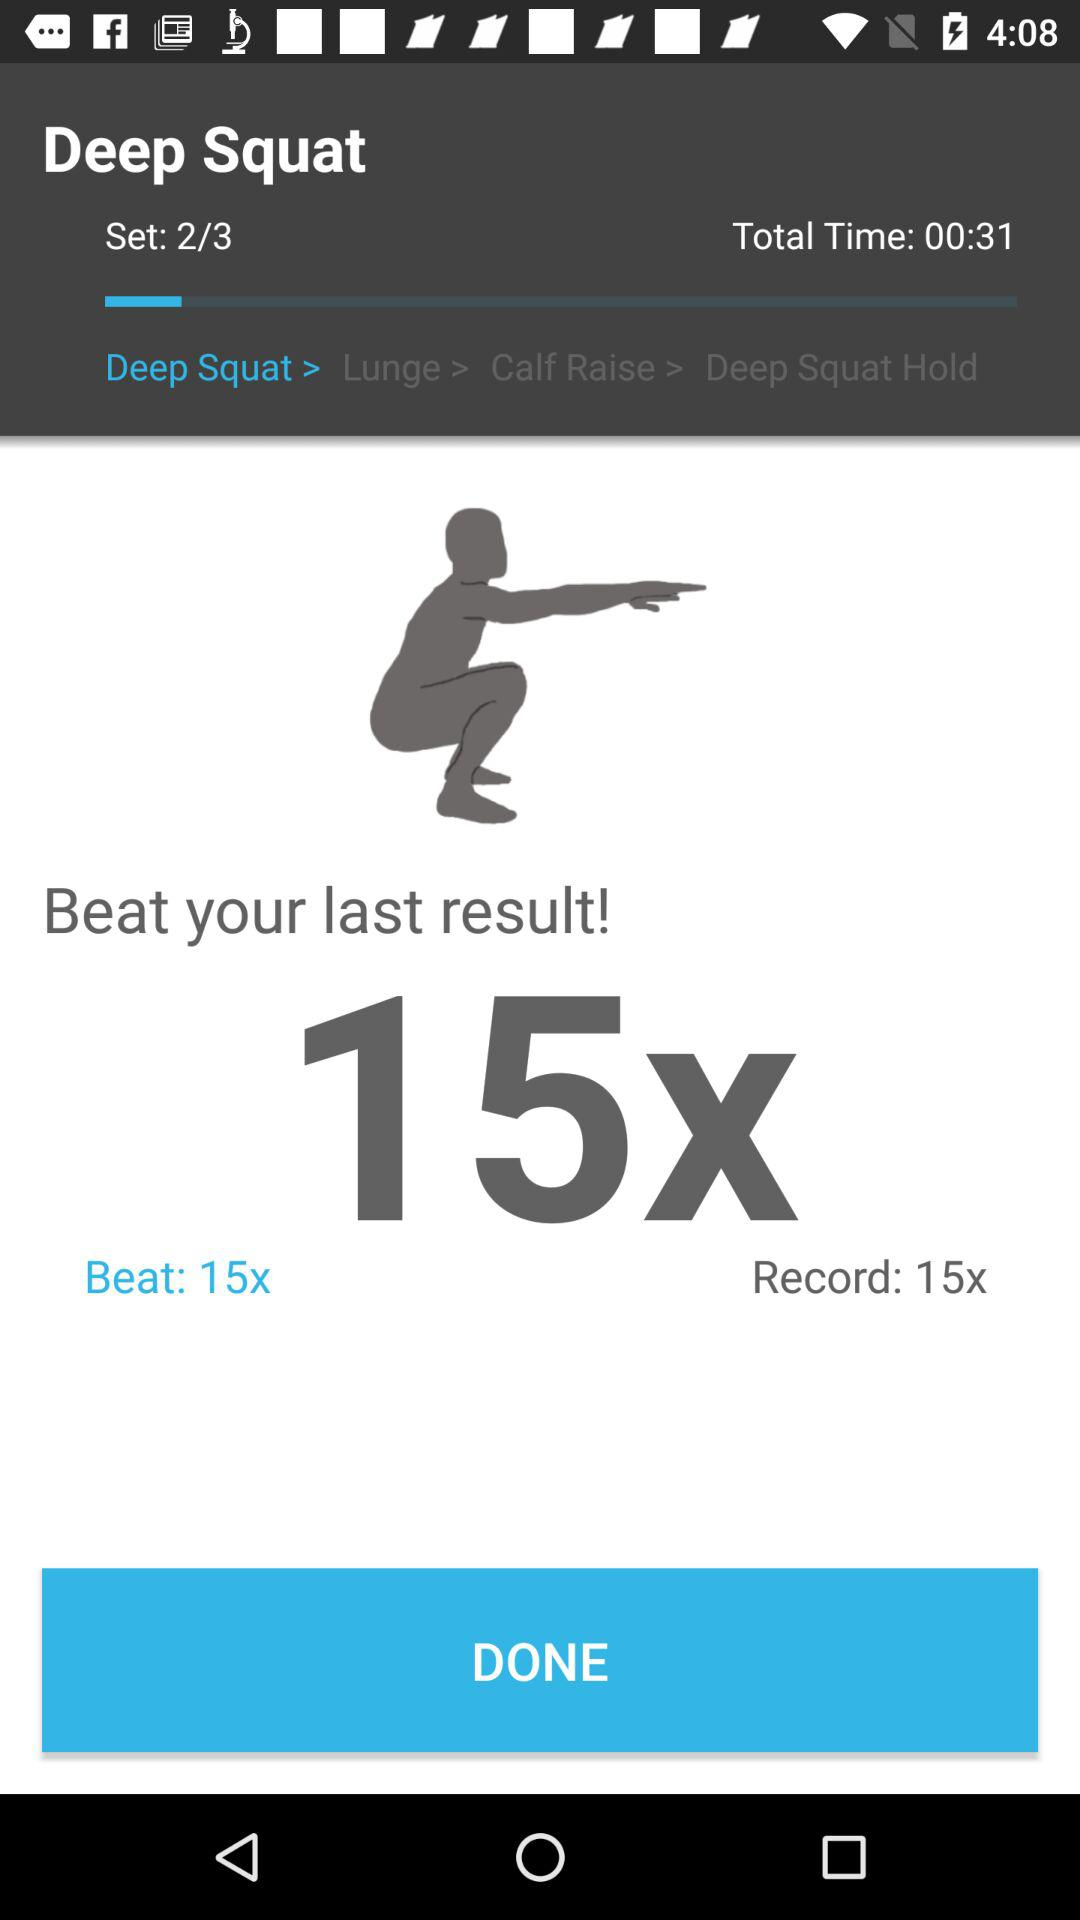How many sets in total are there? There are 3 sets in total. 